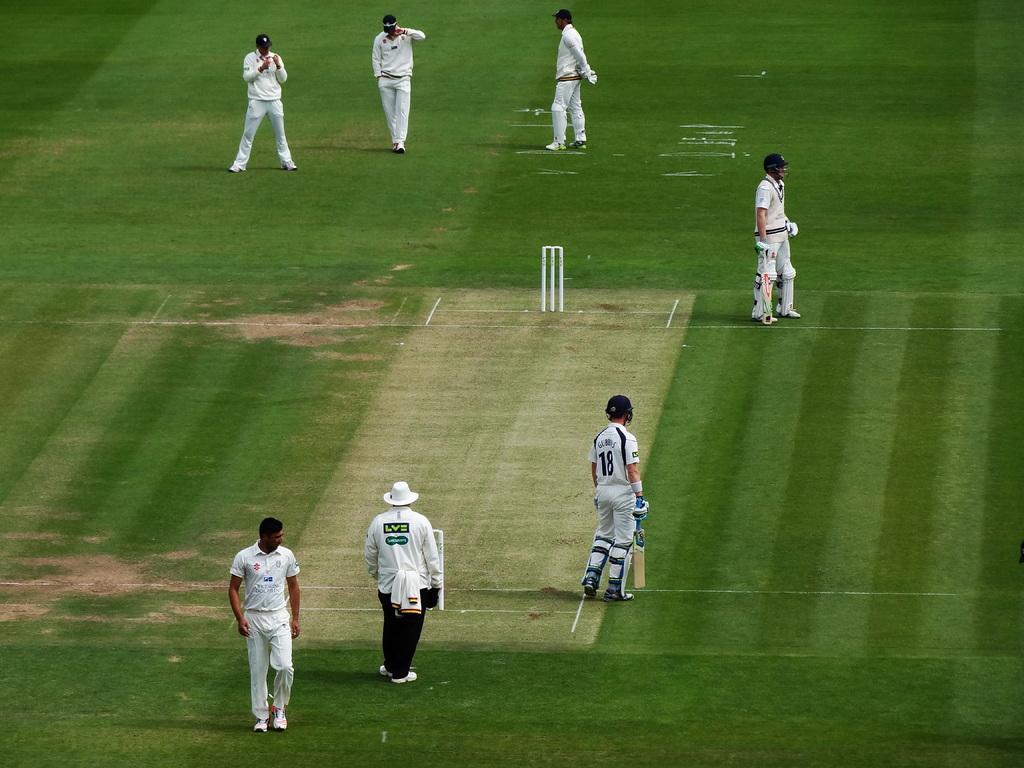Provide a one-sentence caption for the provided image. Man wearing a hat and a shirt that says "LVE" on the back walking on the grass with the players. 